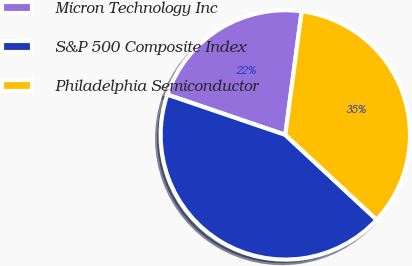Convert chart. <chart><loc_0><loc_0><loc_500><loc_500><pie_chart><fcel>Micron Technology Inc<fcel>S&P 500 Composite Index<fcel>Philadelphia Semiconductor<nl><fcel>21.86%<fcel>43.32%<fcel>34.82%<nl></chart> 